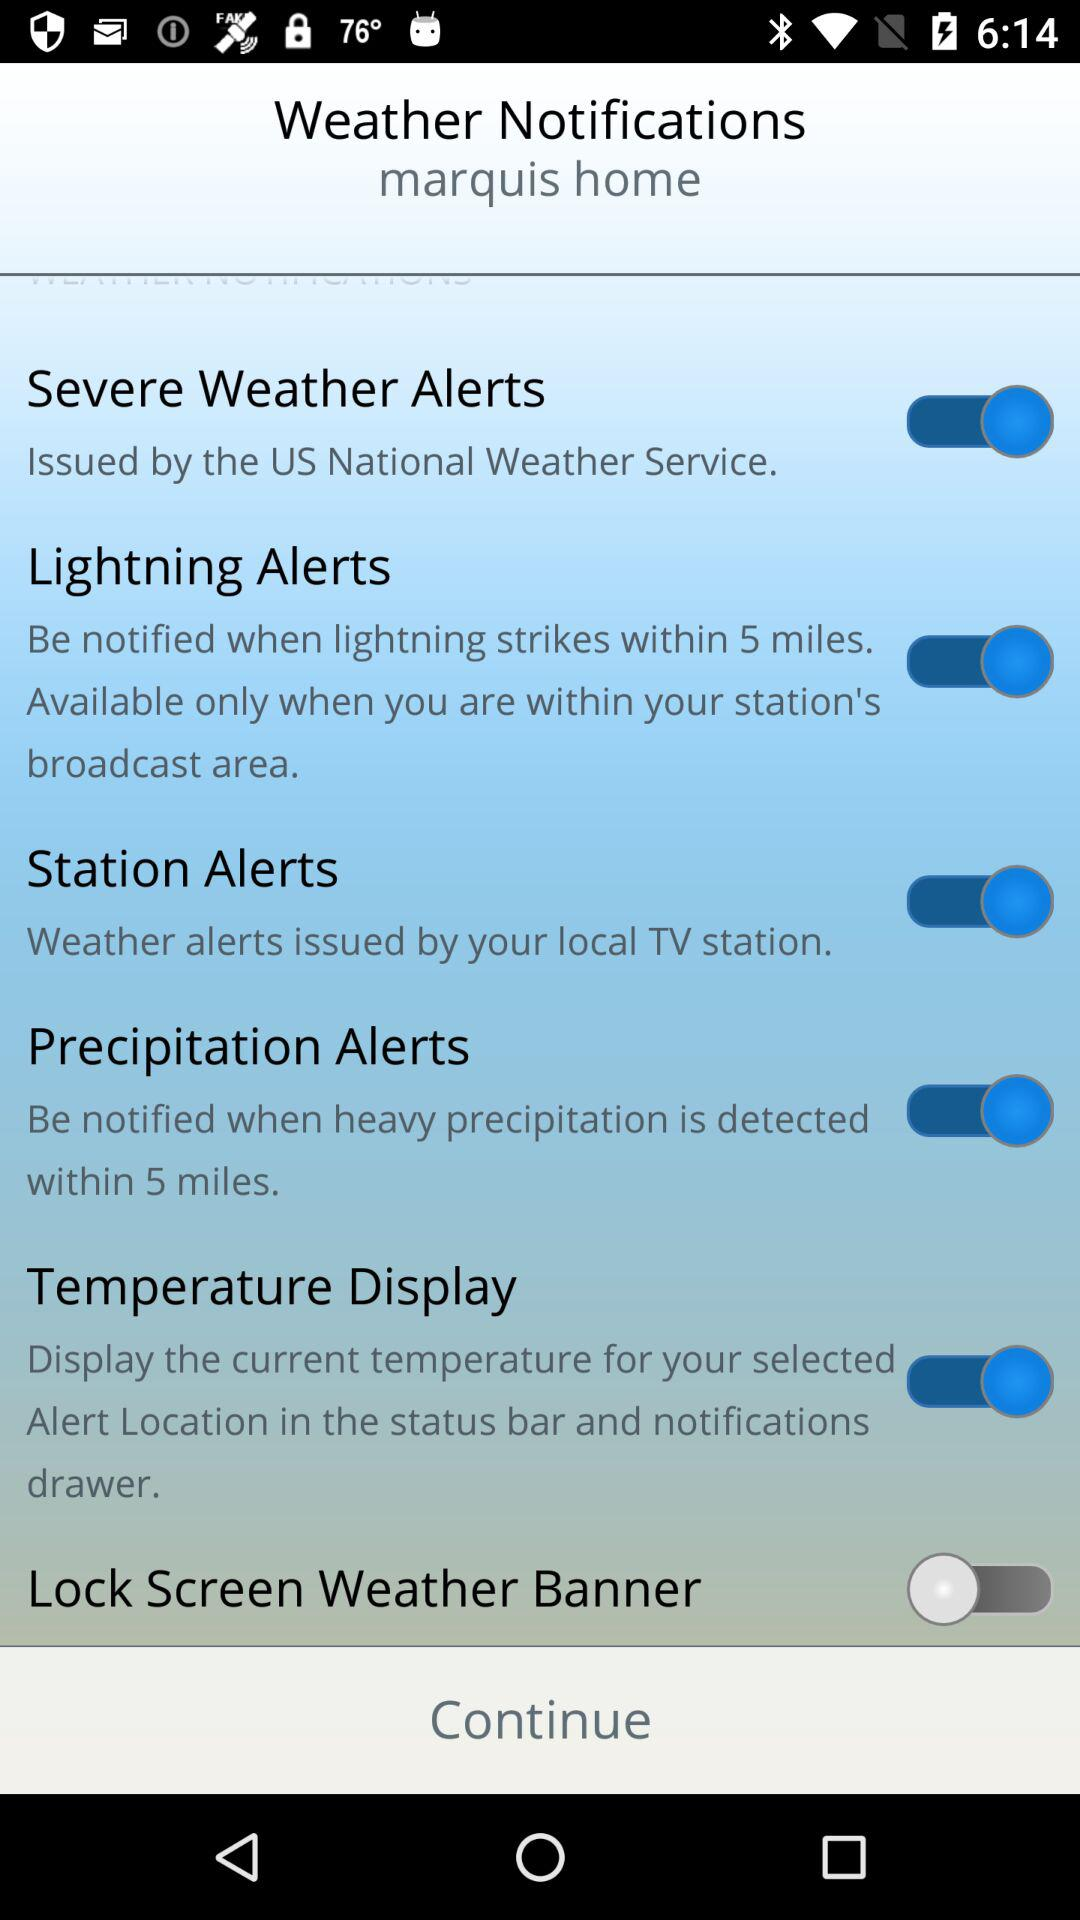Which weather notifications are "on"? The weather notifications that are "on" are "Severe Weather Alerts", "Lightning Alerts", "Station Alerts", "Precipitation Alerts" and "Temperature Display". 